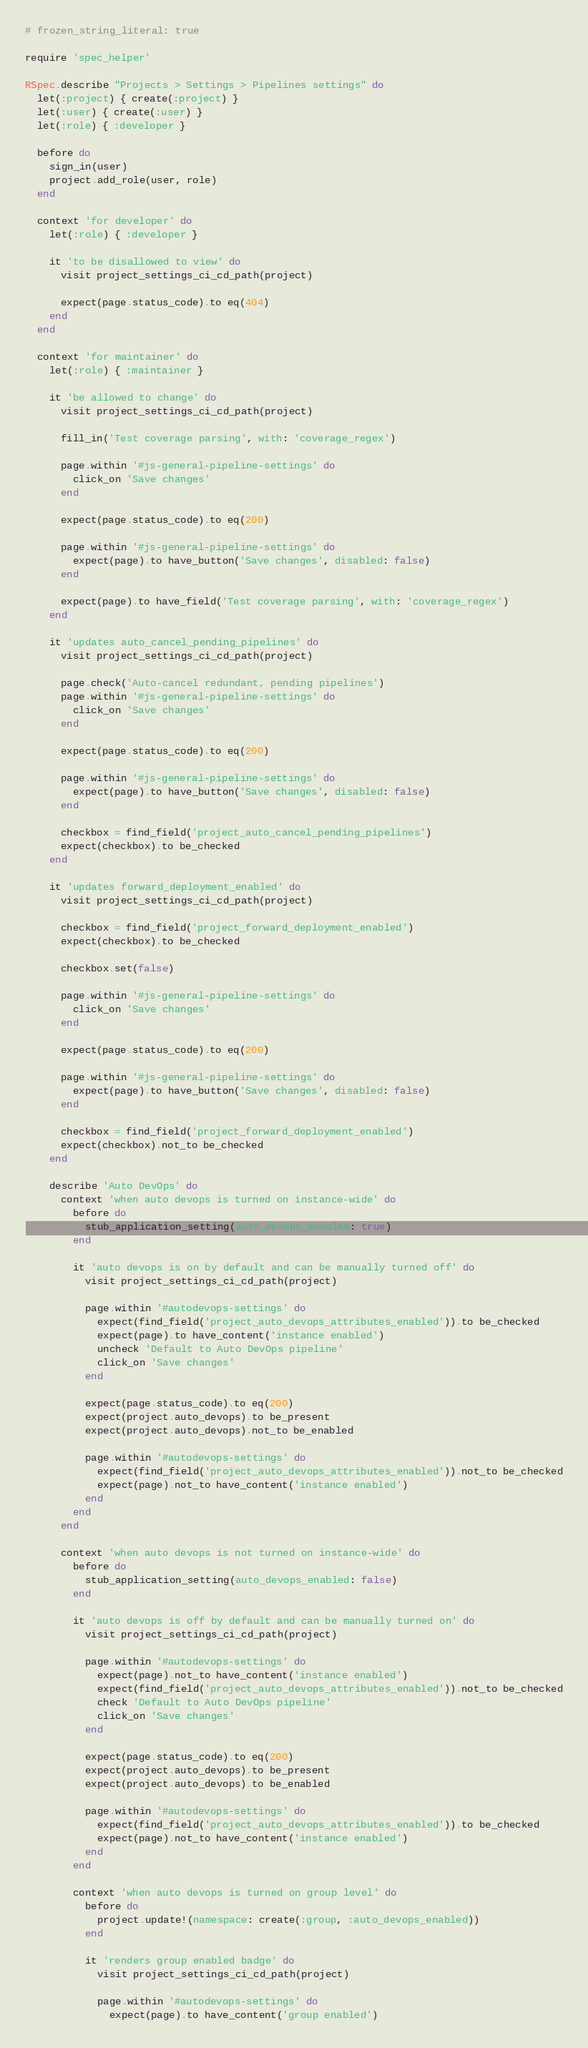Convert code to text. <code><loc_0><loc_0><loc_500><loc_500><_Ruby_># frozen_string_literal: true

require 'spec_helper'

RSpec.describe "Projects > Settings > Pipelines settings" do
  let(:project) { create(:project) }
  let(:user) { create(:user) }
  let(:role) { :developer }

  before do
    sign_in(user)
    project.add_role(user, role)
  end

  context 'for developer' do
    let(:role) { :developer }

    it 'to be disallowed to view' do
      visit project_settings_ci_cd_path(project)

      expect(page.status_code).to eq(404)
    end
  end

  context 'for maintainer' do
    let(:role) { :maintainer }

    it 'be allowed to change' do
      visit project_settings_ci_cd_path(project)

      fill_in('Test coverage parsing', with: 'coverage_regex')

      page.within '#js-general-pipeline-settings' do
        click_on 'Save changes'
      end

      expect(page.status_code).to eq(200)

      page.within '#js-general-pipeline-settings' do
        expect(page).to have_button('Save changes', disabled: false)
      end

      expect(page).to have_field('Test coverage parsing', with: 'coverage_regex')
    end

    it 'updates auto_cancel_pending_pipelines' do
      visit project_settings_ci_cd_path(project)

      page.check('Auto-cancel redundant, pending pipelines')
      page.within '#js-general-pipeline-settings' do
        click_on 'Save changes'
      end

      expect(page.status_code).to eq(200)

      page.within '#js-general-pipeline-settings' do
        expect(page).to have_button('Save changes', disabled: false)
      end

      checkbox = find_field('project_auto_cancel_pending_pipelines')
      expect(checkbox).to be_checked
    end

    it 'updates forward_deployment_enabled' do
      visit project_settings_ci_cd_path(project)

      checkbox = find_field('project_forward_deployment_enabled')
      expect(checkbox).to be_checked

      checkbox.set(false)

      page.within '#js-general-pipeline-settings' do
        click_on 'Save changes'
      end

      expect(page.status_code).to eq(200)

      page.within '#js-general-pipeline-settings' do
        expect(page).to have_button('Save changes', disabled: false)
      end

      checkbox = find_field('project_forward_deployment_enabled')
      expect(checkbox).not_to be_checked
    end

    describe 'Auto DevOps' do
      context 'when auto devops is turned on instance-wide' do
        before do
          stub_application_setting(auto_devops_enabled: true)
        end

        it 'auto devops is on by default and can be manually turned off' do
          visit project_settings_ci_cd_path(project)

          page.within '#autodevops-settings' do
            expect(find_field('project_auto_devops_attributes_enabled')).to be_checked
            expect(page).to have_content('instance enabled')
            uncheck 'Default to Auto DevOps pipeline'
            click_on 'Save changes'
          end

          expect(page.status_code).to eq(200)
          expect(project.auto_devops).to be_present
          expect(project.auto_devops).not_to be_enabled

          page.within '#autodevops-settings' do
            expect(find_field('project_auto_devops_attributes_enabled')).not_to be_checked
            expect(page).not_to have_content('instance enabled')
          end
        end
      end

      context 'when auto devops is not turned on instance-wide' do
        before do
          stub_application_setting(auto_devops_enabled: false)
        end

        it 'auto devops is off by default and can be manually turned on' do
          visit project_settings_ci_cd_path(project)

          page.within '#autodevops-settings' do
            expect(page).not_to have_content('instance enabled')
            expect(find_field('project_auto_devops_attributes_enabled')).not_to be_checked
            check 'Default to Auto DevOps pipeline'
            click_on 'Save changes'
          end

          expect(page.status_code).to eq(200)
          expect(project.auto_devops).to be_present
          expect(project.auto_devops).to be_enabled

          page.within '#autodevops-settings' do
            expect(find_field('project_auto_devops_attributes_enabled')).to be_checked
            expect(page).not_to have_content('instance enabled')
          end
        end

        context 'when auto devops is turned on group level' do
          before do
            project.update!(namespace: create(:group, :auto_devops_enabled))
          end

          it 'renders group enabled badge' do
            visit project_settings_ci_cd_path(project)

            page.within '#autodevops-settings' do
              expect(page).to have_content('group enabled')</code> 